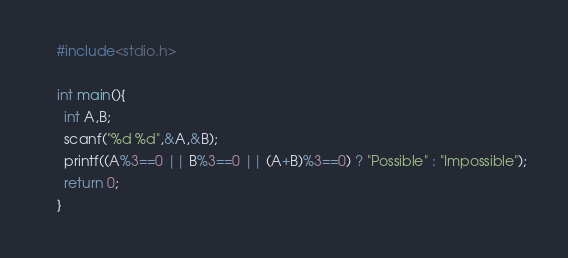<code> <loc_0><loc_0><loc_500><loc_500><_C_>    #include<stdio.h>
     
    int main(){
      int A,B;
      scanf("%d %d",&A,&B);
      printf((A%3==0 || B%3==0 || (A+B)%3==0) ? "Possible" : "Impossible");
      return 0;
    }</code> 